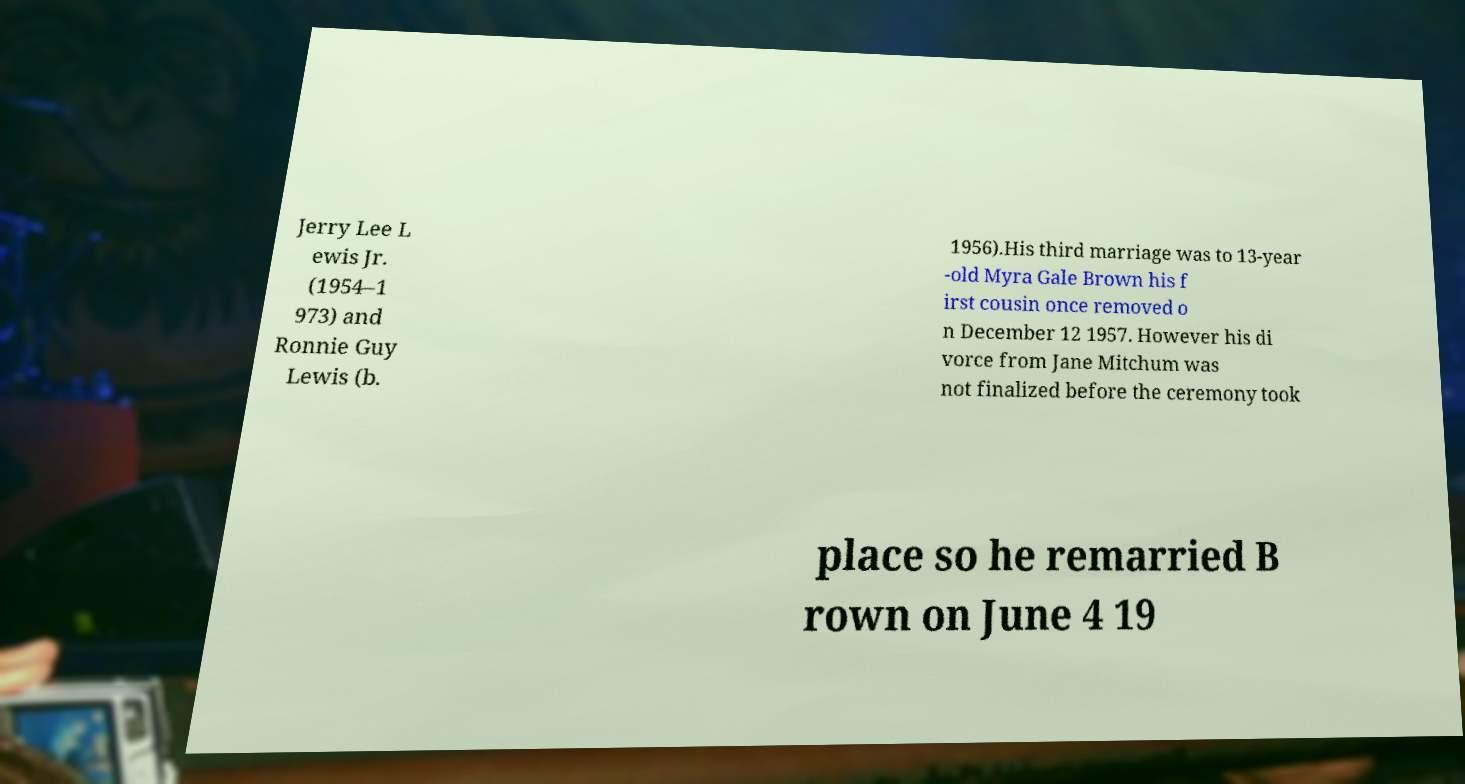Could you assist in decoding the text presented in this image and type it out clearly? Jerry Lee L ewis Jr. (1954–1 973) and Ronnie Guy Lewis (b. 1956).His third marriage was to 13-year -old Myra Gale Brown his f irst cousin once removed o n December 12 1957. However his di vorce from Jane Mitchum was not finalized before the ceremony took place so he remarried B rown on June 4 19 